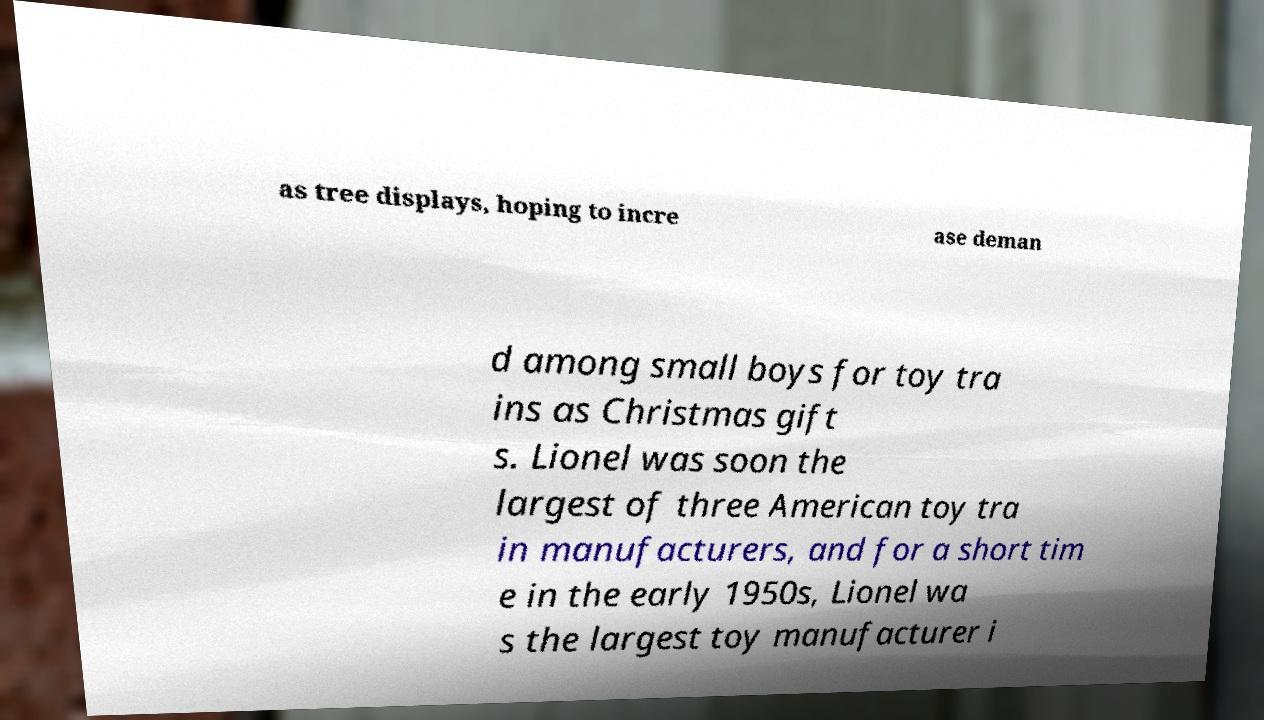Can you read and provide the text displayed in the image?This photo seems to have some interesting text. Can you extract and type it out for me? as tree displays, hoping to incre ase deman d among small boys for toy tra ins as Christmas gift s. Lionel was soon the largest of three American toy tra in manufacturers, and for a short tim e in the early 1950s, Lionel wa s the largest toy manufacturer i 